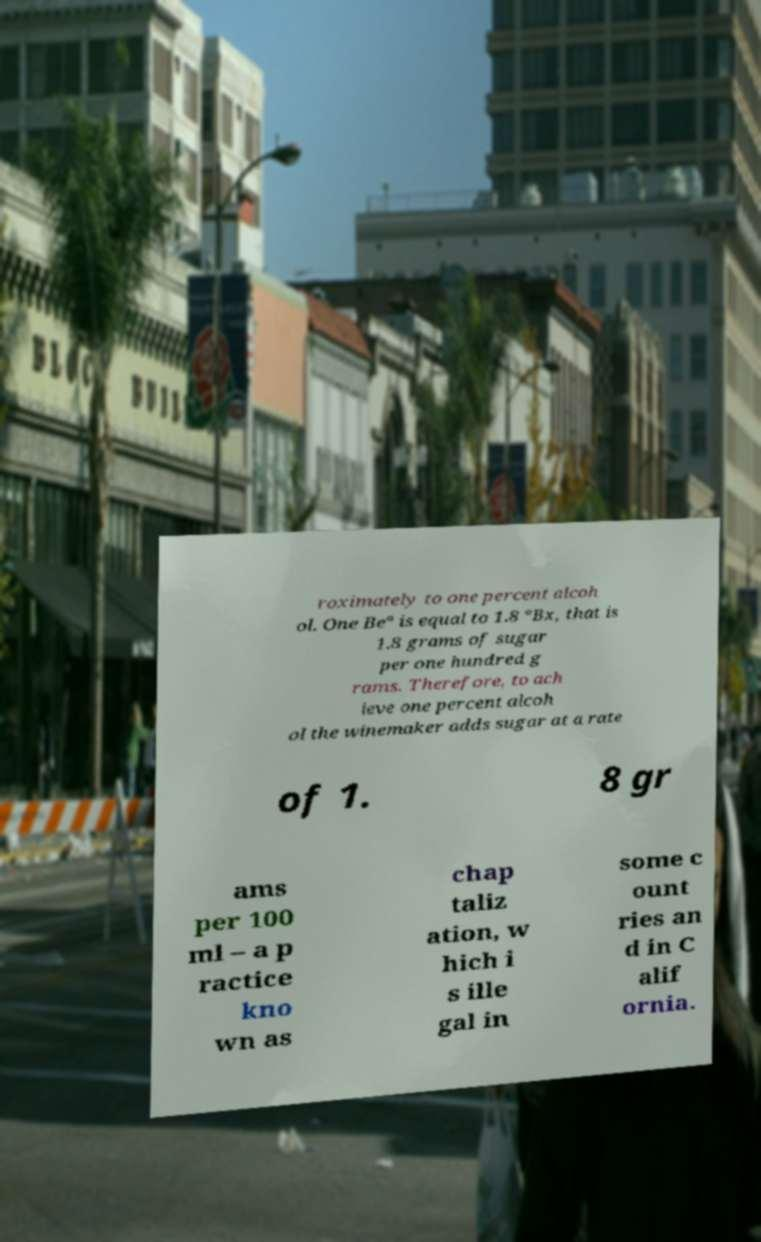Can you read and provide the text displayed in the image?This photo seems to have some interesting text. Can you extract and type it out for me? roximately to one percent alcoh ol. One Be° is equal to 1.8 °Bx, that is 1.8 grams of sugar per one hundred g rams. Therefore, to ach ieve one percent alcoh ol the winemaker adds sugar at a rate of 1. 8 gr ams per 100 ml – a p ractice kno wn as chap taliz ation, w hich i s ille gal in some c ount ries an d in C alif ornia. 